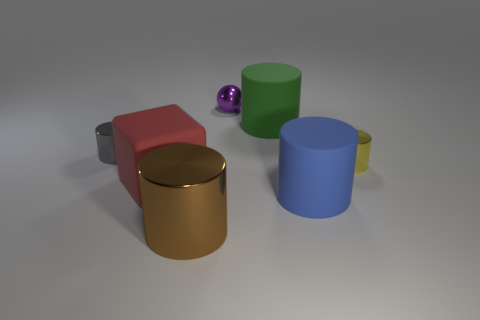Subtract 1 cylinders. How many cylinders are left? 4 Subtract all gray shiny cylinders. How many cylinders are left? 4 Subtract all gray cylinders. How many cylinders are left? 4 Subtract all cyan cylinders. Subtract all brown balls. How many cylinders are left? 5 Add 2 big purple cylinders. How many objects exist? 9 Subtract all cubes. How many objects are left? 6 Subtract 1 blue cylinders. How many objects are left? 6 Subtract all small yellow metal objects. Subtract all metallic balls. How many objects are left? 5 Add 7 large blue cylinders. How many large blue cylinders are left? 8 Add 2 purple balls. How many purple balls exist? 3 